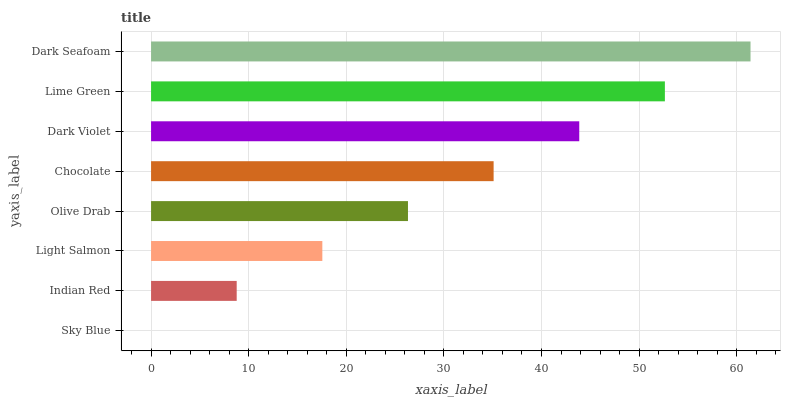Is Sky Blue the minimum?
Answer yes or no. Yes. Is Dark Seafoam the maximum?
Answer yes or no. Yes. Is Indian Red the minimum?
Answer yes or no. No. Is Indian Red the maximum?
Answer yes or no. No. Is Indian Red greater than Sky Blue?
Answer yes or no. Yes. Is Sky Blue less than Indian Red?
Answer yes or no. Yes. Is Sky Blue greater than Indian Red?
Answer yes or no. No. Is Indian Red less than Sky Blue?
Answer yes or no. No. Is Chocolate the high median?
Answer yes or no. Yes. Is Olive Drab the low median?
Answer yes or no. Yes. Is Sky Blue the high median?
Answer yes or no. No. Is Light Salmon the low median?
Answer yes or no. No. 